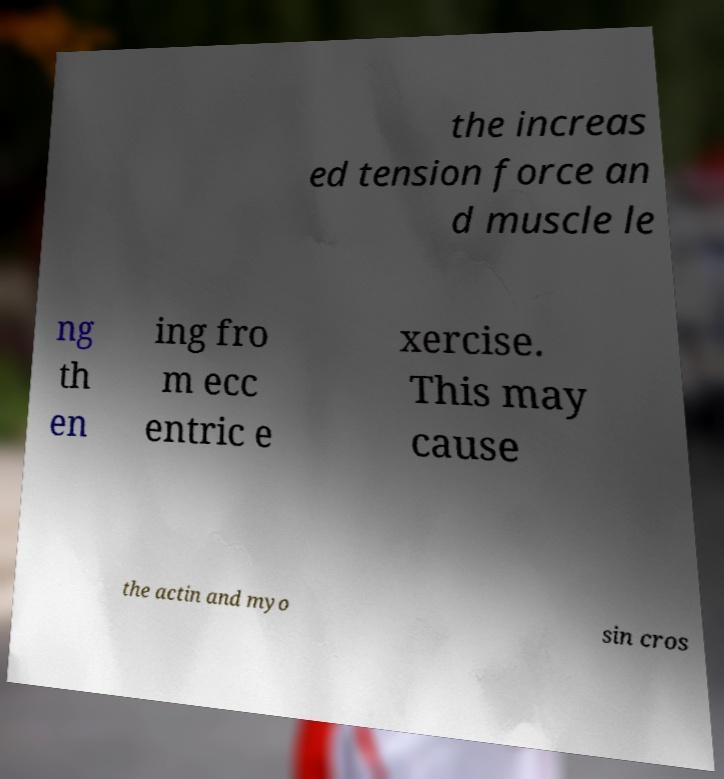Could you extract and type out the text from this image? the increas ed tension force an d muscle le ng th en ing fro m ecc entric e xercise. This may cause the actin and myo sin cros 